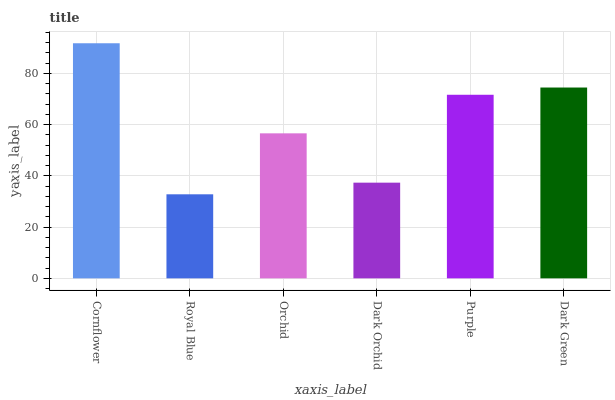Is Royal Blue the minimum?
Answer yes or no. Yes. Is Cornflower the maximum?
Answer yes or no. Yes. Is Orchid the minimum?
Answer yes or no. No. Is Orchid the maximum?
Answer yes or no. No. Is Orchid greater than Royal Blue?
Answer yes or no. Yes. Is Royal Blue less than Orchid?
Answer yes or no. Yes. Is Royal Blue greater than Orchid?
Answer yes or no. No. Is Orchid less than Royal Blue?
Answer yes or no. No. Is Purple the high median?
Answer yes or no. Yes. Is Orchid the low median?
Answer yes or no. Yes. Is Orchid the high median?
Answer yes or no. No. Is Cornflower the low median?
Answer yes or no. No. 